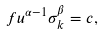<formula> <loc_0><loc_0><loc_500><loc_500>f u ^ { \alpha - 1 } \sigma _ { k } ^ { \beta } = c ,</formula> 